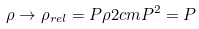<formula> <loc_0><loc_0><loc_500><loc_500>\rho \rightarrow \rho _ { r e l } = P \rho 2 c m P ^ { 2 } = P</formula> 